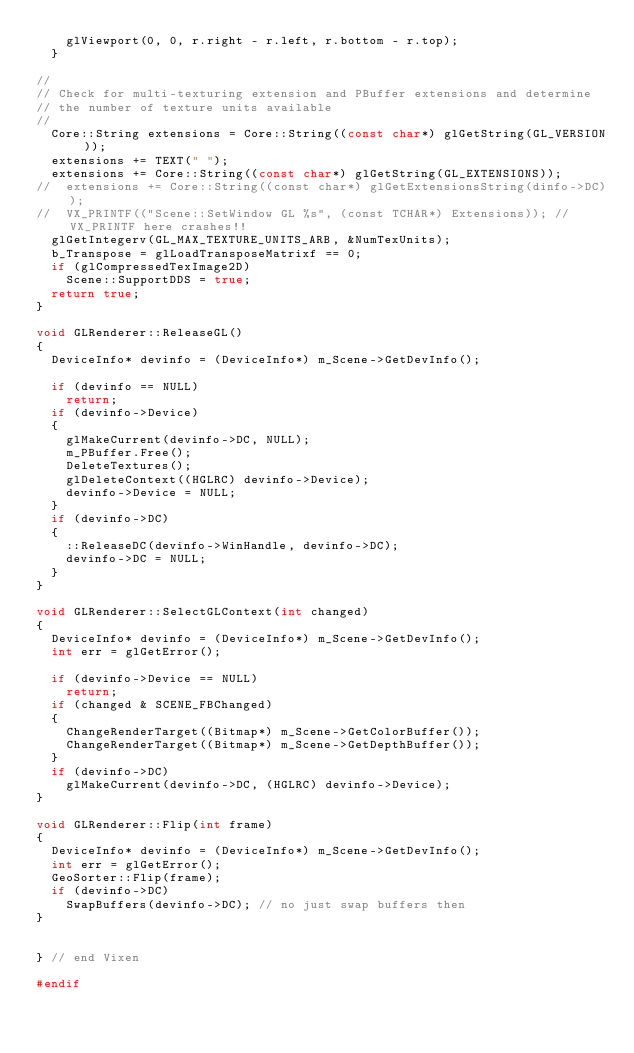<code> <loc_0><loc_0><loc_500><loc_500><_C++_>		glViewport(0, 0, r.right - r.left, r.bottom - r.top);
	}

//
// Check for multi-texturing extension and PBuffer extensions and determine
// the number of texture units available
//
	Core::String extensions = Core::String((const char*) glGetString(GL_VERSION));
	extensions += TEXT(" ");
	extensions += Core::String((const char*) glGetString(GL_EXTENSIONS));
//	extensions += Core::String((const char*) glGetExtensionsString(dinfo->DC));
//	VX_PRINTF(("Scene::SetWindow GL %s", (const TCHAR*) Extensions));	// VX_PRINTF here crashes!!
	glGetIntegerv(GL_MAX_TEXTURE_UNITS_ARB, &NumTexUnits);
	b_Transpose = glLoadTransposeMatrixf == 0;
	if (glCompressedTexImage2D)
		Scene::SupportDDS = true;
 	return true;
}

void GLRenderer::ReleaseGL()
{
	DeviceInfo* devinfo = (DeviceInfo*) m_Scene->GetDevInfo();

	if (devinfo == NULL)
		return;
	if (devinfo->Device)
	{
		glMakeCurrent(devinfo->DC, NULL);
		m_PBuffer.Free();
		DeleteTextures();
		glDeleteContext((HGLRC) devinfo->Device);
		devinfo->Device = NULL;
	}
	if (devinfo->DC)
	{
		::ReleaseDC(devinfo->WinHandle, devinfo->DC);
		devinfo->DC = NULL;
	}
}

void GLRenderer::SelectGLContext(int changed)
{
	DeviceInfo* devinfo = (DeviceInfo*) m_Scene->GetDevInfo();
	int err = glGetError();

	if (devinfo->Device == NULL)
		return;
	if (changed & SCENE_FBChanged)
	{
		ChangeRenderTarget((Bitmap*) m_Scene->GetColorBuffer());
		ChangeRenderTarget((Bitmap*) m_Scene->GetDepthBuffer());
	}
	if (devinfo->DC)
		glMakeCurrent(devinfo->DC, (HGLRC) devinfo->Device);
}

void GLRenderer::Flip(int frame)
{
	DeviceInfo* devinfo = (DeviceInfo*) m_Scene->GetDevInfo();
	int err = glGetError();
	GeoSorter::Flip(frame);
	if (devinfo->DC)
		SwapBuffers(devinfo->DC);	// no just swap buffers then
}


} // end Vixen

#endif</code> 